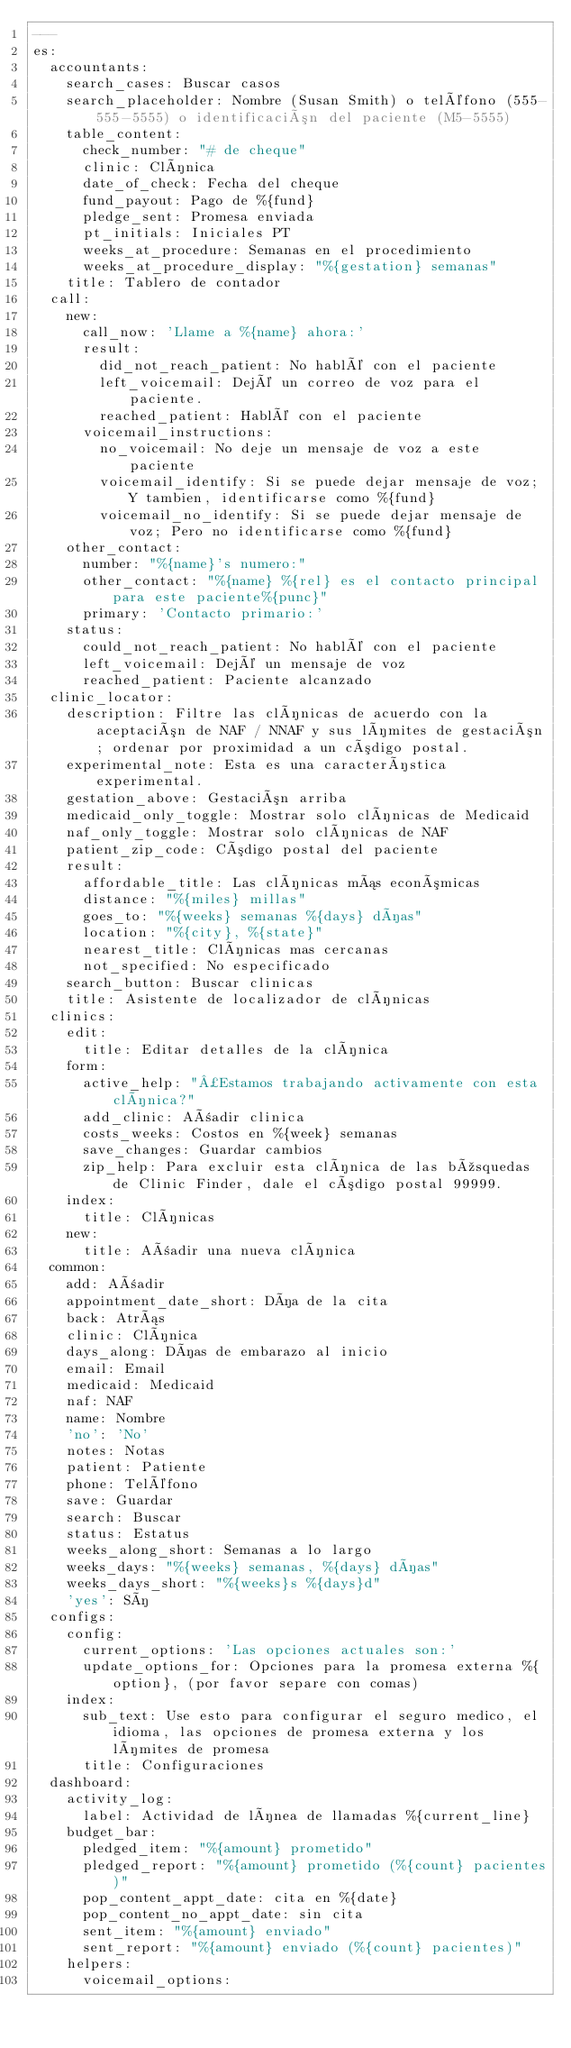<code> <loc_0><loc_0><loc_500><loc_500><_YAML_>---
es:
  accountants:
    search_cases: Buscar casos
    search_placeholder: Nombre (Susan Smith) o teléfono (555-555-5555) o identificación del paciente (M5-5555)
    table_content:
      check_number: "# de cheque"
      clinic: Clínica
      date_of_check: Fecha del cheque
      fund_payout: Pago de %{fund}
      pledge_sent: Promesa enviada
      pt_initials: Iniciales PT
      weeks_at_procedure: Semanas en el procedimiento
      weeks_at_procedure_display: "%{gestation} semanas"
    title: Tablero de contador
  call:
    new:
      call_now: 'Llame a %{name} ahora:'
      result:
        did_not_reach_patient: No hablé con el paciente
        left_voicemail: Dejé un correo de voz para el paciente.
        reached_patient: Hablé con el paciente
      voicemail_instructions:
        no_voicemail: No deje un mensaje de voz a este paciente
        voicemail_identify: Si se puede dejar mensaje de voz; Y tambien, identificarse como %{fund}
        voicemail_no_identify: Si se puede dejar mensaje de voz; Pero no identificarse como %{fund}
    other_contact:
      number: "%{name}'s numero:"
      other_contact: "%{name} %{rel} es el contacto principal para este paciente%{punc}"
      primary: 'Contacto primario:'
    status:
      could_not_reach_patient: No hablé con el paciente
      left_voicemail: Dejé un mensaje de voz
      reached_patient: Paciente alcanzado
  clinic_locator:
    description: Filtre las clínicas de acuerdo con la aceptación de NAF / NNAF y sus límites de gestación; ordenar por proximidad a un código postal.
    experimental_note: Esta es una característica experimental.
    gestation_above: Gestación arriba
    medicaid_only_toggle: Mostrar solo clínicas de Medicaid
    naf_only_toggle: Mostrar solo clínicas de NAF
    patient_zip_code: Código postal del paciente
    result:
      affordable_title: Las clínicas más económicas
      distance: "%{miles} millas"
      goes_to: "%{weeks} semanas %{days} días"
      location: "%{city}, %{state}"
      nearest_title: Clínicas mas cercanas
      not_specified: No especificado
    search_button: Buscar clinicas
    title: Asistente de localizador de clínicas
  clinics:
    edit:
      title: Editar detalles de la clínica
    form:
      active_help: "¿Estamos trabajando activamente con esta clínica?"
      add_clinic: Añadir clinica
      costs_weeks: Costos en %{week} semanas
      save_changes: Guardar cambios
      zip_help: Para excluir esta clínica de las búsquedas de Clinic Finder, dale el código postal 99999.
    index:
      title: Clínicas
    new:
      title: Añadir una nueva clínica
  common:
    add: Añadir
    appointment_date_short: Día de la cita
    back: Atrás
    clinic: Clínica
    days_along: Días de embarazo al inicio
    email: Email
    medicaid: Medicaid
    naf: NAF
    name: Nombre
    'no': 'No'
    notes: Notas
    patient: Patiente
    phone: Teléfono
    save: Guardar
    search: Buscar
    status: Estatus
    weeks_along_short: Semanas a lo largo
    weeks_days: "%{weeks} semanas, %{days} días"
    weeks_days_short: "%{weeks}s %{days}d"
    'yes': Sí
  configs:
    config:
      current_options: 'Las opciones actuales son:'
      update_options_for: Opciones para la promesa externa %{option}, (por favor separe con comas)
    index:
      sub_text: Use esto para configurar el seguro medico, el idioma, las opciones de promesa externa y los límites de promesa
      title: Configuraciones
  dashboard:
    activity_log:
      label: Actividad de línea de llamadas %{current_line}
    budget_bar:
      pledged_item: "%{amount} prometido"
      pledged_report: "%{amount} prometido (%{count} pacientes)"
      pop_content_appt_date: cita en %{date}
      pop_content_no_appt_date: sin cita
      sent_item: "%{amount} enviado"
      sent_report: "%{amount} enviado (%{count} pacientes)"
    helpers:
      voicemail_options:</code> 